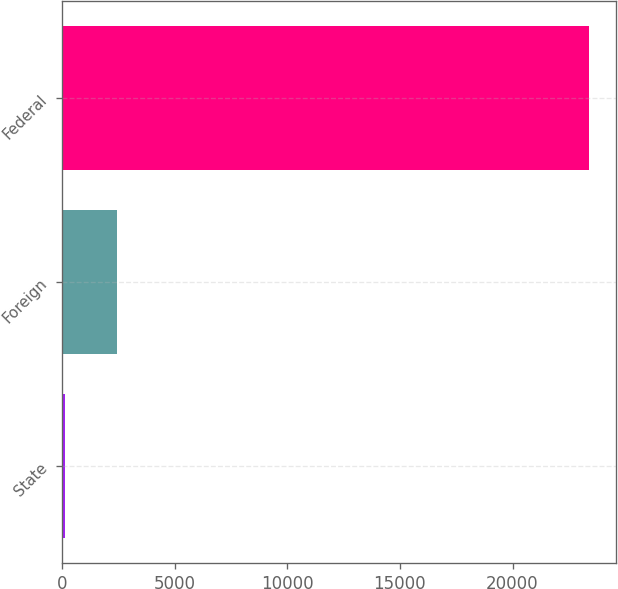<chart> <loc_0><loc_0><loc_500><loc_500><bar_chart><fcel>State<fcel>Foreign<fcel>Federal<nl><fcel>132<fcel>2459.3<fcel>23405<nl></chart> 